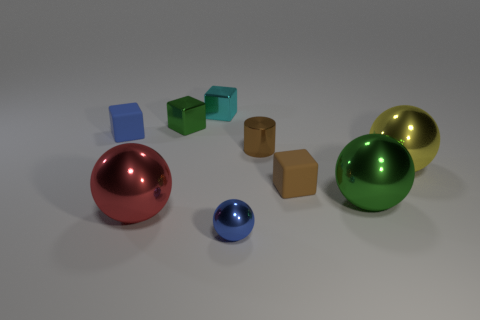How many things are either cubes that are in front of the small green cube or small cyan metallic blocks?
Provide a succinct answer. 3. What number of other things are there of the same size as the cyan shiny object?
Ensure brevity in your answer.  5. There is a green object that is in front of the green cube; what size is it?
Ensure brevity in your answer.  Large. There is a object that is the same material as the tiny brown cube; what shape is it?
Your answer should be very brief. Cube. Is there any other thing that has the same color as the metallic cylinder?
Your answer should be compact. Yes. There is a sphere behind the tiny cube that is in front of the yellow thing; what is its color?
Provide a short and direct response. Yellow. How many big things are metallic cubes or spheres?
Your response must be concise. 3. There is a tiny blue thing that is the same shape as the brown matte object; what is its material?
Ensure brevity in your answer.  Rubber. The small sphere is what color?
Your answer should be very brief. Blue. Is the cylinder the same color as the tiny ball?
Ensure brevity in your answer.  No. 